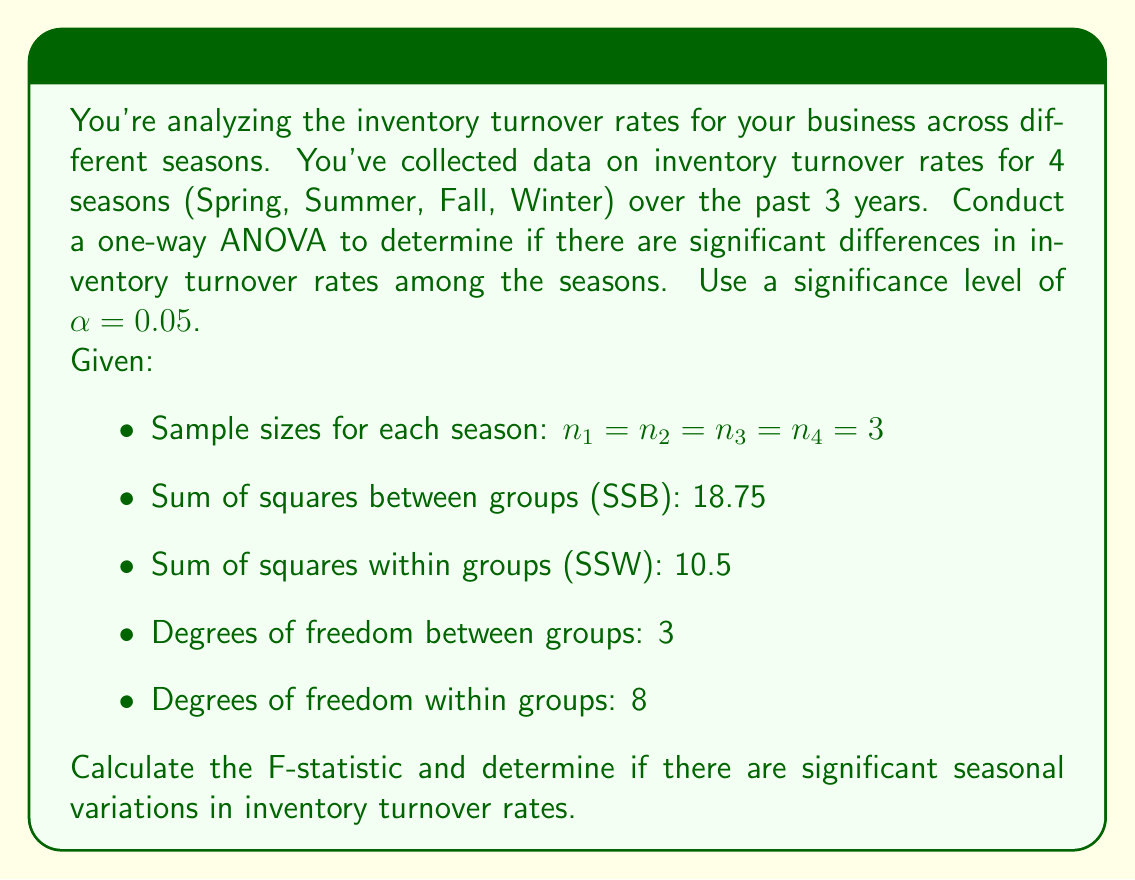Show me your answer to this math problem. To solve this problem, we'll follow these steps:

1. Calculate the mean square between groups (MSB) and mean square within groups (MSW):
   
   MSB = SSB / df_between = $18.75 / 3 = 6.25$
   MSW = SSW / df_within = $10.5 / 8 = 1.3125$

2. Calculate the F-statistic:
   
   $F = \frac{MSB}{MSW} = \frac{6.25}{1.3125} = 4.7619$

3. Determine the critical F-value:
   
   With α = 0.05, df_between = 3, and df_within = 8, we can look up the critical F-value in an F-distribution table or use a calculator. The critical F-value is approximately 4.0662.

4. Compare the calculated F-statistic to the critical F-value:
   
   Since $4.7619 > 4.0662$, we reject the null hypothesis.

5. Interpret the results:
   
   The calculated F-statistic (4.7619) is greater than the critical F-value (4.0662), which means we reject the null hypothesis at the 0.05 significance level. This suggests that there are significant differences in inventory turnover rates among the seasons.
Answer: F-statistic = 4.7619

There are significant seasonal variations in inventory turnover rates (p < 0.05). 